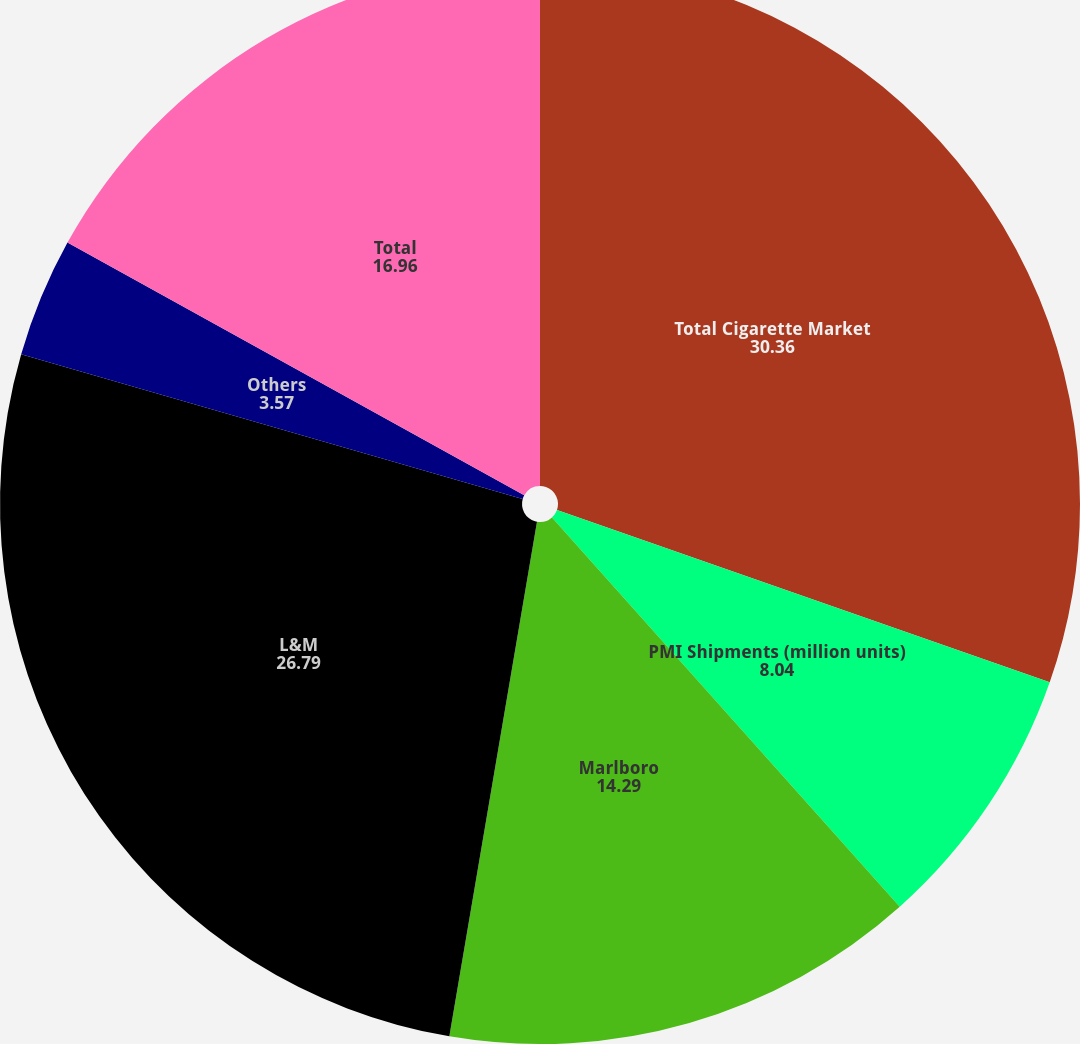Convert chart to OTSL. <chart><loc_0><loc_0><loc_500><loc_500><pie_chart><fcel>Total Cigarette Market<fcel>PMI Shipments (million units)<fcel>Marlboro<fcel>L&M<fcel>Others<fcel>Total<nl><fcel>30.36%<fcel>8.04%<fcel>14.29%<fcel>26.79%<fcel>3.57%<fcel>16.96%<nl></chart> 